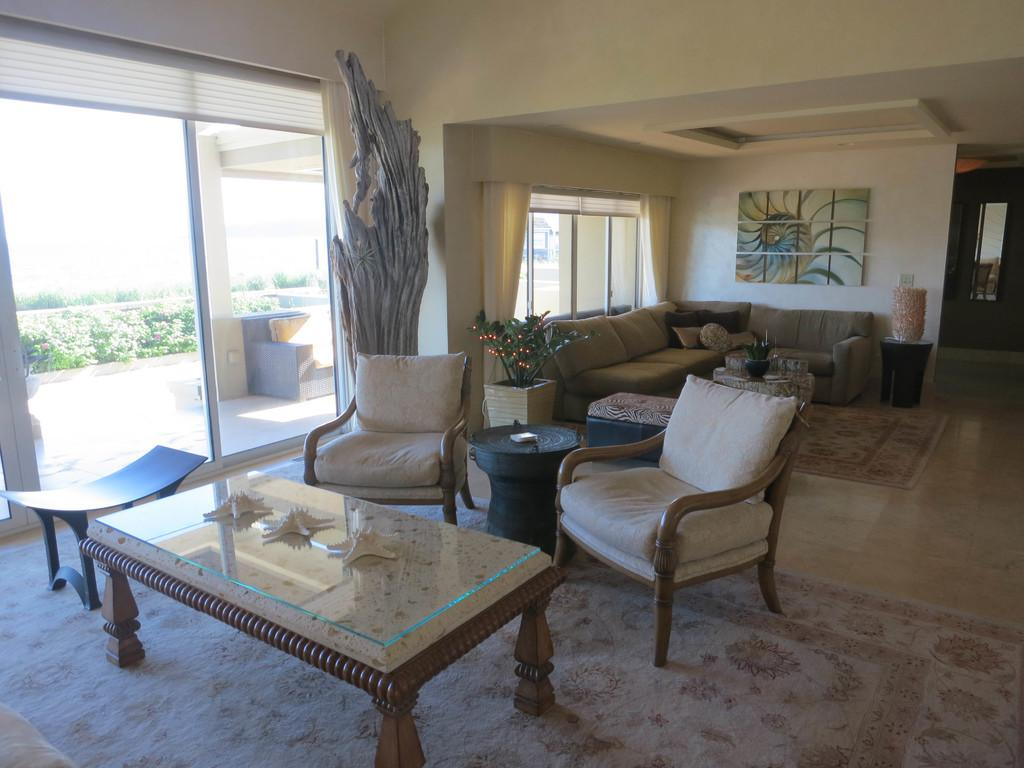What is the color of the wall in the image? The wall in the image is white. What can be seen hanging on the wall? There is a photo frame in the image. What allows natural light to enter the room in the image? There are windows in the image. What type of furniture is present in the room for seating? There are sofas and chairs in the image. What piece of furniture is present for placing objects or serving food? There is a table in the image. What type of drink is being served in the downtown area in the image? There is no reference to a downtown area or any drinks in the image; it only features a white wall, a photo frame, windows, sofas, chairs, and a table. 